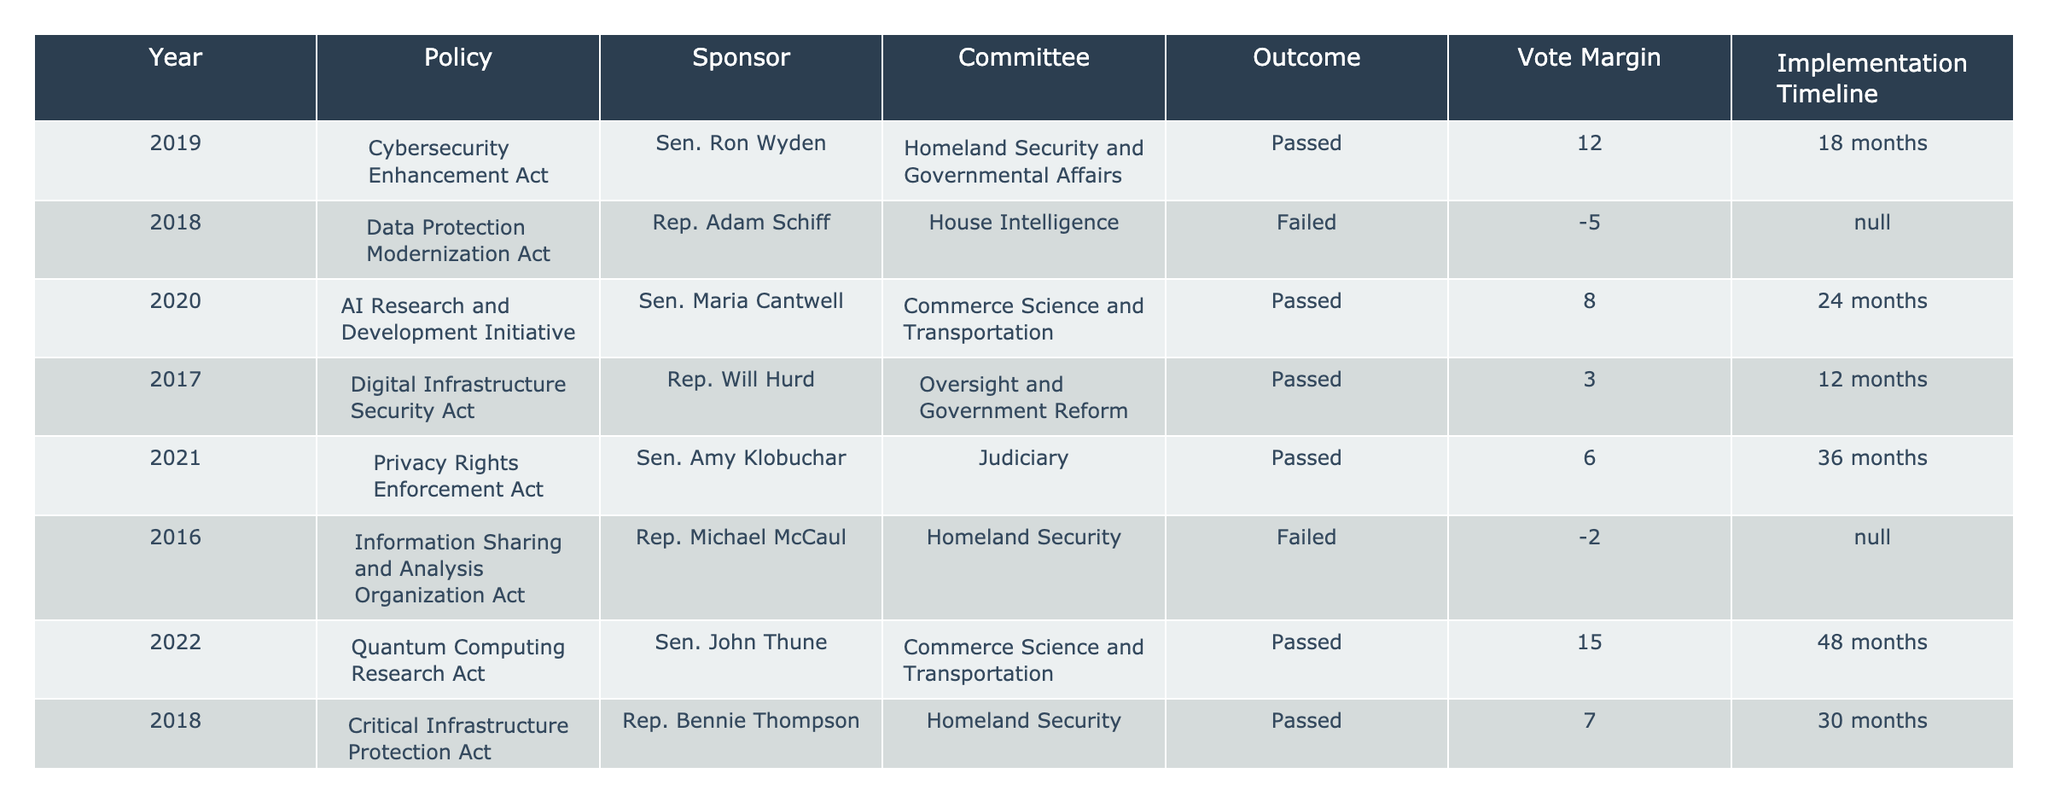What was the outcome of the Privacy Rights Enforcement Act? The Privacy Rights Enforcement Act, sponsored by Sen. Amy Klobuchar in 2021, is listed as "Passed" in the Outcome column of the table.
Answer: Passed How many policies were sponsored by Rep. Will Hurd? The table shows that Rep. Will Hurd sponsored one policy, the Digital Infrastructure Security Act, listed in 2017.
Answer: 1 What is the vote margin for the Quantum Computing Research Act? The Quantum Computing Research Act, sponsored by Sen. John Thune in 2022, has a vote margin of 15, as indicated in the Vote Margin column.
Answer: 15 Which policy had the longest implementation timeline? The policy with the longest implementation timeline is the Quantum Computing Research Act, which has an implementation timeline of 48 months, as noted in the Implementation Timeline column.
Answer: 48 months What percentage of policies had a failed outcome? There are two failed policies out of ten total policies (Data Protection Modernization Act and the Information Sharing and Analysis Organization Act), giving a percentage of (2/10)*100 = 20%.
Answer: 20% What is the average vote margin of all the passed policies? The passed policies have vote margins of 12, 8, 3, 6, 15, 9, 11, and 4. Adding these gives 68. There are 8 passed policies, so the average is 68/8 = 8.5.
Answer: 8.5 Did any failed policies have a sponsor from the Senate? Reviewing the table, both failed policies were sponsored by Representatives (Rep. Adam Schiff and Rep. Michael McCaul), so there were no failed policies sponsored by a Senator.
Answer: No Which policy had the smallest vote margin? The policy with the smallest vote margin is the Digital Infrastructure Security Act, which had a vote margin of 3, as shown in the Vote Margin column.
Answer: 3 If we account for the years 2019 to 2021, how many policies passed? In the years 2019 to 2021, the policies that passed are the Cybersecurity Enhancement Act (2019), Digital Infrastructure Security Act (2017), Privacy Rights Enforcement Act (2021), Data Breach Notification Act (2021), and Cloud Security Enhancement Act (2017). That totals five passed policies within those years.
Answer: 5 What was the outcome of the Federal IT Modernization Act? According to the table, the Federal IT Modernization Act, sponsored by Sen. Gary Peters in 2020, was "Passed" in the Outcome column.
Answer: Passed 